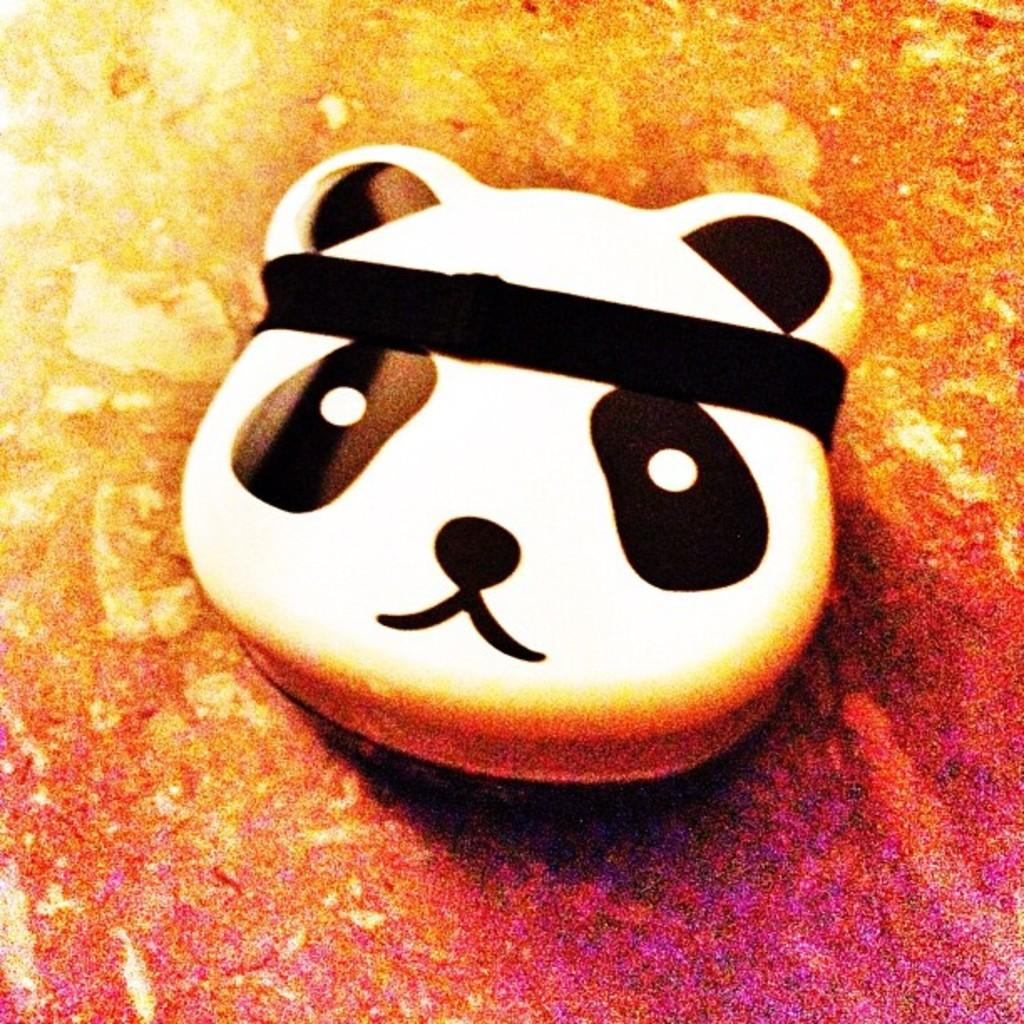What type of toy is in the picture? There is a panda toy in the picture. Where is the panda toy located? The panda toy is placed on a surface. What story is the panda toy attempting to tell in the image? There is no story or attempt to tell a story present in the image; it simply shows a panda toy placed on a surface. 